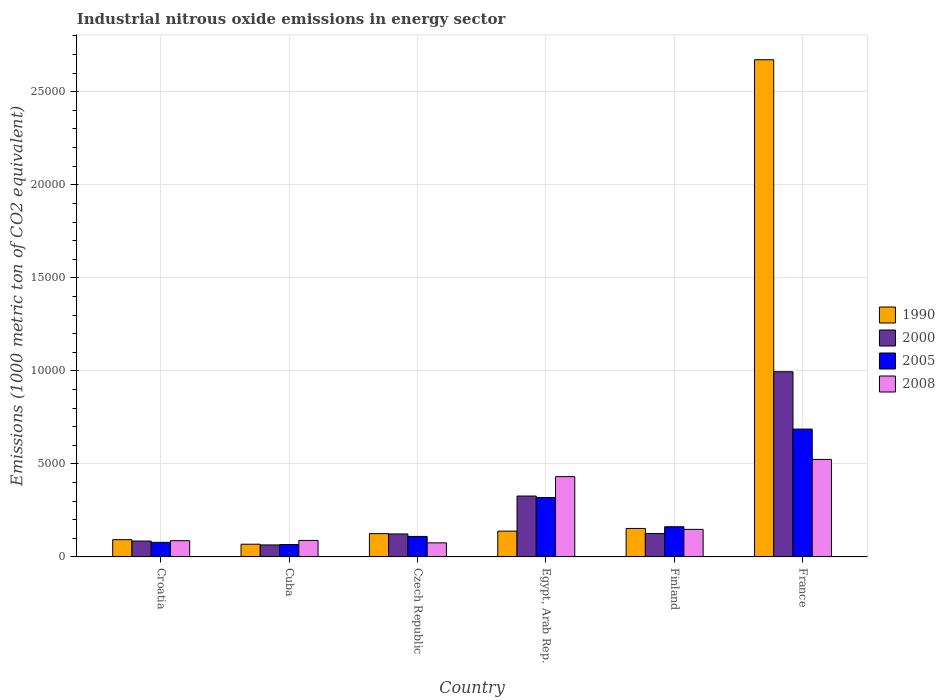How many groups of bars are there?
Give a very brief answer. 6. How many bars are there on the 3rd tick from the left?
Provide a succinct answer. 4. How many bars are there on the 3rd tick from the right?
Provide a short and direct response. 4. What is the label of the 5th group of bars from the left?
Ensure brevity in your answer.  Finland. What is the amount of industrial nitrous oxide emitted in 2000 in France?
Offer a terse response. 9953.8. Across all countries, what is the maximum amount of industrial nitrous oxide emitted in 2005?
Provide a succinct answer. 6871.6. Across all countries, what is the minimum amount of industrial nitrous oxide emitted in 2005?
Your answer should be very brief. 667.1. In which country was the amount of industrial nitrous oxide emitted in 1990 maximum?
Give a very brief answer. France. In which country was the amount of industrial nitrous oxide emitted in 2008 minimum?
Give a very brief answer. Czech Republic. What is the total amount of industrial nitrous oxide emitted in 2008 in the graph?
Keep it short and to the point. 1.36e+04. What is the difference between the amount of industrial nitrous oxide emitted in 2005 in Egypt, Arab Rep. and that in France?
Give a very brief answer. -3679. What is the difference between the amount of industrial nitrous oxide emitted in 2000 in Czech Republic and the amount of industrial nitrous oxide emitted in 2005 in Egypt, Arab Rep.?
Provide a short and direct response. -1957.2. What is the average amount of industrial nitrous oxide emitted in 1990 per country?
Offer a terse response. 5417.4. What is the difference between the amount of industrial nitrous oxide emitted of/in 2008 and amount of industrial nitrous oxide emitted of/in 1990 in France?
Your response must be concise. -2.15e+04. What is the ratio of the amount of industrial nitrous oxide emitted in 2000 in Croatia to that in Cuba?
Provide a succinct answer. 1.32. What is the difference between the highest and the second highest amount of industrial nitrous oxide emitted in 1990?
Provide a succinct answer. 2.52e+04. What is the difference between the highest and the lowest amount of industrial nitrous oxide emitted in 2000?
Make the answer very short. 9308.8. Is the sum of the amount of industrial nitrous oxide emitted in 2000 in Croatia and Finland greater than the maximum amount of industrial nitrous oxide emitted in 2005 across all countries?
Give a very brief answer. No. Is it the case that in every country, the sum of the amount of industrial nitrous oxide emitted in 1990 and amount of industrial nitrous oxide emitted in 2008 is greater than the sum of amount of industrial nitrous oxide emitted in 2005 and amount of industrial nitrous oxide emitted in 2000?
Give a very brief answer. No. What does the 4th bar from the left in Czech Republic represents?
Ensure brevity in your answer.  2008. What does the 4th bar from the right in Czech Republic represents?
Give a very brief answer. 1990. How many bars are there?
Offer a terse response. 24. Are all the bars in the graph horizontal?
Give a very brief answer. No. Does the graph contain grids?
Keep it short and to the point. Yes. Where does the legend appear in the graph?
Give a very brief answer. Center right. What is the title of the graph?
Your response must be concise. Industrial nitrous oxide emissions in energy sector. Does "1964" appear as one of the legend labels in the graph?
Give a very brief answer. No. What is the label or title of the Y-axis?
Ensure brevity in your answer.  Emissions (1000 metric ton of CO2 equivalent). What is the Emissions (1000 metric ton of CO2 equivalent) of 1990 in Croatia?
Your response must be concise. 927.7. What is the Emissions (1000 metric ton of CO2 equivalent) in 2000 in Croatia?
Offer a terse response. 854.3. What is the Emissions (1000 metric ton of CO2 equivalent) in 2005 in Croatia?
Ensure brevity in your answer.  783.2. What is the Emissions (1000 metric ton of CO2 equivalent) in 2008 in Croatia?
Give a very brief answer. 873. What is the Emissions (1000 metric ton of CO2 equivalent) in 1990 in Cuba?
Keep it short and to the point. 683.6. What is the Emissions (1000 metric ton of CO2 equivalent) of 2000 in Cuba?
Your answer should be very brief. 645. What is the Emissions (1000 metric ton of CO2 equivalent) of 2005 in Cuba?
Keep it short and to the point. 667.1. What is the Emissions (1000 metric ton of CO2 equivalent) in 2008 in Cuba?
Ensure brevity in your answer.  886.9. What is the Emissions (1000 metric ton of CO2 equivalent) of 1990 in Czech Republic?
Ensure brevity in your answer.  1253.3. What is the Emissions (1000 metric ton of CO2 equivalent) in 2000 in Czech Republic?
Make the answer very short. 1235.4. What is the Emissions (1000 metric ton of CO2 equivalent) of 2005 in Czech Republic?
Give a very brief answer. 1101.5. What is the Emissions (1000 metric ton of CO2 equivalent) of 2008 in Czech Republic?
Make the answer very short. 756. What is the Emissions (1000 metric ton of CO2 equivalent) of 1990 in Egypt, Arab Rep.?
Provide a succinct answer. 1386.6. What is the Emissions (1000 metric ton of CO2 equivalent) of 2000 in Egypt, Arab Rep.?
Offer a terse response. 3272.7. What is the Emissions (1000 metric ton of CO2 equivalent) of 2005 in Egypt, Arab Rep.?
Give a very brief answer. 3192.6. What is the Emissions (1000 metric ton of CO2 equivalent) of 2008 in Egypt, Arab Rep.?
Ensure brevity in your answer.  4315. What is the Emissions (1000 metric ton of CO2 equivalent) of 1990 in Finland?
Offer a very short reply. 1530.9. What is the Emissions (1000 metric ton of CO2 equivalent) in 2000 in Finland?
Your answer should be very brief. 1259.4. What is the Emissions (1000 metric ton of CO2 equivalent) in 2005 in Finland?
Your answer should be compact. 1622.4. What is the Emissions (1000 metric ton of CO2 equivalent) of 2008 in Finland?
Your answer should be very brief. 1481.5. What is the Emissions (1000 metric ton of CO2 equivalent) of 1990 in France?
Provide a short and direct response. 2.67e+04. What is the Emissions (1000 metric ton of CO2 equivalent) of 2000 in France?
Ensure brevity in your answer.  9953.8. What is the Emissions (1000 metric ton of CO2 equivalent) of 2005 in France?
Provide a succinct answer. 6871.6. What is the Emissions (1000 metric ton of CO2 equivalent) in 2008 in France?
Give a very brief answer. 5241.3. Across all countries, what is the maximum Emissions (1000 metric ton of CO2 equivalent) in 1990?
Offer a very short reply. 2.67e+04. Across all countries, what is the maximum Emissions (1000 metric ton of CO2 equivalent) of 2000?
Offer a terse response. 9953.8. Across all countries, what is the maximum Emissions (1000 metric ton of CO2 equivalent) of 2005?
Provide a short and direct response. 6871.6. Across all countries, what is the maximum Emissions (1000 metric ton of CO2 equivalent) in 2008?
Your answer should be compact. 5241.3. Across all countries, what is the minimum Emissions (1000 metric ton of CO2 equivalent) of 1990?
Give a very brief answer. 683.6. Across all countries, what is the minimum Emissions (1000 metric ton of CO2 equivalent) of 2000?
Give a very brief answer. 645. Across all countries, what is the minimum Emissions (1000 metric ton of CO2 equivalent) of 2005?
Your answer should be compact. 667.1. Across all countries, what is the minimum Emissions (1000 metric ton of CO2 equivalent) in 2008?
Make the answer very short. 756. What is the total Emissions (1000 metric ton of CO2 equivalent) in 1990 in the graph?
Make the answer very short. 3.25e+04. What is the total Emissions (1000 metric ton of CO2 equivalent) of 2000 in the graph?
Your response must be concise. 1.72e+04. What is the total Emissions (1000 metric ton of CO2 equivalent) in 2005 in the graph?
Your answer should be very brief. 1.42e+04. What is the total Emissions (1000 metric ton of CO2 equivalent) in 2008 in the graph?
Your answer should be very brief. 1.36e+04. What is the difference between the Emissions (1000 metric ton of CO2 equivalent) in 1990 in Croatia and that in Cuba?
Offer a terse response. 244.1. What is the difference between the Emissions (1000 metric ton of CO2 equivalent) of 2000 in Croatia and that in Cuba?
Your answer should be compact. 209.3. What is the difference between the Emissions (1000 metric ton of CO2 equivalent) in 2005 in Croatia and that in Cuba?
Provide a short and direct response. 116.1. What is the difference between the Emissions (1000 metric ton of CO2 equivalent) of 2008 in Croatia and that in Cuba?
Offer a terse response. -13.9. What is the difference between the Emissions (1000 metric ton of CO2 equivalent) in 1990 in Croatia and that in Czech Republic?
Offer a terse response. -325.6. What is the difference between the Emissions (1000 metric ton of CO2 equivalent) of 2000 in Croatia and that in Czech Republic?
Make the answer very short. -381.1. What is the difference between the Emissions (1000 metric ton of CO2 equivalent) of 2005 in Croatia and that in Czech Republic?
Your answer should be compact. -318.3. What is the difference between the Emissions (1000 metric ton of CO2 equivalent) of 2008 in Croatia and that in Czech Republic?
Your answer should be very brief. 117. What is the difference between the Emissions (1000 metric ton of CO2 equivalent) in 1990 in Croatia and that in Egypt, Arab Rep.?
Your answer should be compact. -458.9. What is the difference between the Emissions (1000 metric ton of CO2 equivalent) in 2000 in Croatia and that in Egypt, Arab Rep.?
Make the answer very short. -2418.4. What is the difference between the Emissions (1000 metric ton of CO2 equivalent) of 2005 in Croatia and that in Egypt, Arab Rep.?
Your answer should be compact. -2409.4. What is the difference between the Emissions (1000 metric ton of CO2 equivalent) in 2008 in Croatia and that in Egypt, Arab Rep.?
Keep it short and to the point. -3442. What is the difference between the Emissions (1000 metric ton of CO2 equivalent) in 1990 in Croatia and that in Finland?
Keep it short and to the point. -603.2. What is the difference between the Emissions (1000 metric ton of CO2 equivalent) in 2000 in Croatia and that in Finland?
Keep it short and to the point. -405.1. What is the difference between the Emissions (1000 metric ton of CO2 equivalent) of 2005 in Croatia and that in Finland?
Give a very brief answer. -839.2. What is the difference between the Emissions (1000 metric ton of CO2 equivalent) in 2008 in Croatia and that in Finland?
Ensure brevity in your answer.  -608.5. What is the difference between the Emissions (1000 metric ton of CO2 equivalent) in 1990 in Croatia and that in France?
Give a very brief answer. -2.58e+04. What is the difference between the Emissions (1000 metric ton of CO2 equivalent) in 2000 in Croatia and that in France?
Offer a terse response. -9099.5. What is the difference between the Emissions (1000 metric ton of CO2 equivalent) of 2005 in Croatia and that in France?
Your response must be concise. -6088.4. What is the difference between the Emissions (1000 metric ton of CO2 equivalent) in 2008 in Croatia and that in France?
Offer a terse response. -4368.3. What is the difference between the Emissions (1000 metric ton of CO2 equivalent) in 1990 in Cuba and that in Czech Republic?
Ensure brevity in your answer.  -569.7. What is the difference between the Emissions (1000 metric ton of CO2 equivalent) of 2000 in Cuba and that in Czech Republic?
Offer a very short reply. -590.4. What is the difference between the Emissions (1000 metric ton of CO2 equivalent) in 2005 in Cuba and that in Czech Republic?
Make the answer very short. -434.4. What is the difference between the Emissions (1000 metric ton of CO2 equivalent) of 2008 in Cuba and that in Czech Republic?
Keep it short and to the point. 130.9. What is the difference between the Emissions (1000 metric ton of CO2 equivalent) in 1990 in Cuba and that in Egypt, Arab Rep.?
Provide a short and direct response. -703. What is the difference between the Emissions (1000 metric ton of CO2 equivalent) in 2000 in Cuba and that in Egypt, Arab Rep.?
Offer a very short reply. -2627.7. What is the difference between the Emissions (1000 metric ton of CO2 equivalent) in 2005 in Cuba and that in Egypt, Arab Rep.?
Make the answer very short. -2525.5. What is the difference between the Emissions (1000 metric ton of CO2 equivalent) in 2008 in Cuba and that in Egypt, Arab Rep.?
Give a very brief answer. -3428.1. What is the difference between the Emissions (1000 metric ton of CO2 equivalent) in 1990 in Cuba and that in Finland?
Provide a short and direct response. -847.3. What is the difference between the Emissions (1000 metric ton of CO2 equivalent) of 2000 in Cuba and that in Finland?
Your response must be concise. -614.4. What is the difference between the Emissions (1000 metric ton of CO2 equivalent) in 2005 in Cuba and that in Finland?
Offer a very short reply. -955.3. What is the difference between the Emissions (1000 metric ton of CO2 equivalent) of 2008 in Cuba and that in Finland?
Provide a succinct answer. -594.6. What is the difference between the Emissions (1000 metric ton of CO2 equivalent) in 1990 in Cuba and that in France?
Provide a succinct answer. -2.60e+04. What is the difference between the Emissions (1000 metric ton of CO2 equivalent) of 2000 in Cuba and that in France?
Make the answer very short. -9308.8. What is the difference between the Emissions (1000 metric ton of CO2 equivalent) of 2005 in Cuba and that in France?
Provide a short and direct response. -6204.5. What is the difference between the Emissions (1000 metric ton of CO2 equivalent) of 2008 in Cuba and that in France?
Provide a succinct answer. -4354.4. What is the difference between the Emissions (1000 metric ton of CO2 equivalent) in 1990 in Czech Republic and that in Egypt, Arab Rep.?
Your answer should be very brief. -133.3. What is the difference between the Emissions (1000 metric ton of CO2 equivalent) of 2000 in Czech Republic and that in Egypt, Arab Rep.?
Offer a terse response. -2037.3. What is the difference between the Emissions (1000 metric ton of CO2 equivalent) of 2005 in Czech Republic and that in Egypt, Arab Rep.?
Provide a succinct answer. -2091.1. What is the difference between the Emissions (1000 metric ton of CO2 equivalent) in 2008 in Czech Republic and that in Egypt, Arab Rep.?
Make the answer very short. -3559. What is the difference between the Emissions (1000 metric ton of CO2 equivalent) of 1990 in Czech Republic and that in Finland?
Provide a short and direct response. -277.6. What is the difference between the Emissions (1000 metric ton of CO2 equivalent) in 2000 in Czech Republic and that in Finland?
Offer a very short reply. -24. What is the difference between the Emissions (1000 metric ton of CO2 equivalent) of 2005 in Czech Republic and that in Finland?
Offer a terse response. -520.9. What is the difference between the Emissions (1000 metric ton of CO2 equivalent) in 2008 in Czech Republic and that in Finland?
Offer a terse response. -725.5. What is the difference between the Emissions (1000 metric ton of CO2 equivalent) in 1990 in Czech Republic and that in France?
Your response must be concise. -2.55e+04. What is the difference between the Emissions (1000 metric ton of CO2 equivalent) of 2000 in Czech Republic and that in France?
Provide a succinct answer. -8718.4. What is the difference between the Emissions (1000 metric ton of CO2 equivalent) in 2005 in Czech Republic and that in France?
Your response must be concise. -5770.1. What is the difference between the Emissions (1000 metric ton of CO2 equivalent) in 2008 in Czech Republic and that in France?
Offer a very short reply. -4485.3. What is the difference between the Emissions (1000 metric ton of CO2 equivalent) in 1990 in Egypt, Arab Rep. and that in Finland?
Offer a terse response. -144.3. What is the difference between the Emissions (1000 metric ton of CO2 equivalent) of 2000 in Egypt, Arab Rep. and that in Finland?
Ensure brevity in your answer.  2013.3. What is the difference between the Emissions (1000 metric ton of CO2 equivalent) in 2005 in Egypt, Arab Rep. and that in Finland?
Offer a terse response. 1570.2. What is the difference between the Emissions (1000 metric ton of CO2 equivalent) in 2008 in Egypt, Arab Rep. and that in Finland?
Offer a very short reply. 2833.5. What is the difference between the Emissions (1000 metric ton of CO2 equivalent) in 1990 in Egypt, Arab Rep. and that in France?
Provide a succinct answer. -2.53e+04. What is the difference between the Emissions (1000 metric ton of CO2 equivalent) in 2000 in Egypt, Arab Rep. and that in France?
Your response must be concise. -6681.1. What is the difference between the Emissions (1000 metric ton of CO2 equivalent) in 2005 in Egypt, Arab Rep. and that in France?
Your answer should be very brief. -3679. What is the difference between the Emissions (1000 metric ton of CO2 equivalent) of 2008 in Egypt, Arab Rep. and that in France?
Your response must be concise. -926.3. What is the difference between the Emissions (1000 metric ton of CO2 equivalent) of 1990 in Finland and that in France?
Offer a very short reply. -2.52e+04. What is the difference between the Emissions (1000 metric ton of CO2 equivalent) of 2000 in Finland and that in France?
Your response must be concise. -8694.4. What is the difference between the Emissions (1000 metric ton of CO2 equivalent) in 2005 in Finland and that in France?
Offer a very short reply. -5249.2. What is the difference between the Emissions (1000 metric ton of CO2 equivalent) in 2008 in Finland and that in France?
Make the answer very short. -3759.8. What is the difference between the Emissions (1000 metric ton of CO2 equivalent) of 1990 in Croatia and the Emissions (1000 metric ton of CO2 equivalent) of 2000 in Cuba?
Give a very brief answer. 282.7. What is the difference between the Emissions (1000 metric ton of CO2 equivalent) in 1990 in Croatia and the Emissions (1000 metric ton of CO2 equivalent) in 2005 in Cuba?
Provide a succinct answer. 260.6. What is the difference between the Emissions (1000 metric ton of CO2 equivalent) of 1990 in Croatia and the Emissions (1000 metric ton of CO2 equivalent) of 2008 in Cuba?
Offer a very short reply. 40.8. What is the difference between the Emissions (1000 metric ton of CO2 equivalent) of 2000 in Croatia and the Emissions (1000 metric ton of CO2 equivalent) of 2005 in Cuba?
Offer a terse response. 187.2. What is the difference between the Emissions (1000 metric ton of CO2 equivalent) in 2000 in Croatia and the Emissions (1000 metric ton of CO2 equivalent) in 2008 in Cuba?
Make the answer very short. -32.6. What is the difference between the Emissions (1000 metric ton of CO2 equivalent) in 2005 in Croatia and the Emissions (1000 metric ton of CO2 equivalent) in 2008 in Cuba?
Offer a very short reply. -103.7. What is the difference between the Emissions (1000 metric ton of CO2 equivalent) of 1990 in Croatia and the Emissions (1000 metric ton of CO2 equivalent) of 2000 in Czech Republic?
Provide a short and direct response. -307.7. What is the difference between the Emissions (1000 metric ton of CO2 equivalent) in 1990 in Croatia and the Emissions (1000 metric ton of CO2 equivalent) in 2005 in Czech Republic?
Provide a short and direct response. -173.8. What is the difference between the Emissions (1000 metric ton of CO2 equivalent) in 1990 in Croatia and the Emissions (1000 metric ton of CO2 equivalent) in 2008 in Czech Republic?
Your answer should be very brief. 171.7. What is the difference between the Emissions (1000 metric ton of CO2 equivalent) of 2000 in Croatia and the Emissions (1000 metric ton of CO2 equivalent) of 2005 in Czech Republic?
Your response must be concise. -247.2. What is the difference between the Emissions (1000 metric ton of CO2 equivalent) in 2000 in Croatia and the Emissions (1000 metric ton of CO2 equivalent) in 2008 in Czech Republic?
Make the answer very short. 98.3. What is the difference between the Emissions (1000 metric ton of CO2 equivalent) in 2005 in Croatia and the Emissions (1000 metric ton of CO2 equivalent) in 2008 in Czech Republic?
Provide a succinct answer. 27.2. What is the difference between the Emissions (1000 metric ton of CO2 equivalent) in 1990 in Croatia and the Emissions (1000 metric ton of CO2 equivalent) in 2000 in Egypt, Arab Rep.?
Ensure brevity in your answer.  -2345. What is the difference between the Emissions (1000 metric ton of CO2 equivalent) in 1990 in Croatia and the Emissions (1000 metric ton of CO2 equivalent) in 2005 in Egypt, Arab Rep.?
Ensure brevity in your answer.  -2264.9. What is the difference between the Emissions (1000 metric ton of CO2 equivalent) in 1990 in Croatia and the Emissions (1000 metric ton of CO2 equivalent) in 2008 in Egypt, Arab Rep.?
Keep it short and to the point. -3387.3. What is the difference between the Emissions (1000 metric ton of CO2 equivalent) in 2000 in Croatia and the Emissions (1000 metric ton of CO2 equivalent) in 2005 in Egypt, Arab Rep.?
Give a very brief answer. -2338.3. What is the difference between the Emissions (1000 metric ton of CO2 equivalent) of 2000 in Croatia and the Emissions (1000 metric ton of CO2 equivalent) of 2008 in Egypt, Arab Rep.?
Give a very brief answer. -3460.7. What is the difference between the Emissions (1000 metric ton of CO2 equivalent) of 2005 in Croatia and the Emissions (1000 metric ton of CO2 equivalent) of 2008 in Egypt, Arab Rep.?
Your answer should be very brief. -3531.8. What is the difference between the Emissions (1000 metric ton of CO2 equivalent) in 1990 in Croatia and the Emissions (1000 metric ton of CO2 equivalent) in 2000 in Finland?
Provide a short and direct response. -331.7. What is the difference between the Emissions (1000 metric ton of CO2 equivalent) of 1990 in Croatia and the Emissions (1000 metric ton of CO2 equivalent) of 2005 in Finland?
Make the answer very short. -694.7. What is the difference between the Emissions (1000 metric ton of CO2 equivalent) in 1990 in Croatia and the Emissions (1000 metric ton of CO2 equivalent) in 2008 in Finland?
Make the answer very short. -553.8. What is the difference between the Emissions (1000 metric ton of CO2 equivalent) of 2000 in Croatia and the Emissions (1000 metric ton of CO2 equivalent) of 2005 in Finland?
Keep it short and to the point. -768.1. What is the difference between the Emissions (1000 metric ton of CO2 equivalent) of 2000 in Croatia and the Emissions (1000 metric ton of CO2 equivalent) of 2008 in Finland?
Give a very brief answer. -627.2. What is the difference between the Emissions (1000 metric ton of CO2 equivalent) of 2005 in Croatia and the Emissions (1000 metric ton of CO2 equivalent) of 2008 in Finland?
Offer a very short reply. -698.3. What is the difference between the Emissions (1000 metric ton of CO2 equivalent) in 1990 in Croatia and the Emissions (1000 metric ton of CO2 equivalent) in 2000 in France?
Your response must be concise. -9026.1. What is the difference between the Emissions (1000 metric ton of CO2 equivalent) in 1990 in Croatia and the Emissions (1000 metric ton of CO2 equivalent) in 2005 in France?
Your answer should be compact. -5943.9. What is the difference between the Emissions (1000 metric ton of CO2 equivalent) in 1990 in Croatia and the Emissions (1000 metric ton of CO2 equivalent) in 2008 in France?
Give a very brief answer. -4313.6. What is the difference between the Emissions (1000 metric ton of CO2 equivalent) in 2000 in Croatia and the Emissions (1000 metric ton of CO2 equivalent) in 2005 in France?
Ensure brevity in your answer.  -6017.3. What is the difference between the Emissions (1000 metric ton of CO2 equivalent) of 2000 in Croatia and the Emissions (1000 metric ton of CO2 equivalent) of 2008 in France?
Your answer should be compact. -4387. What is the difference between the Emissions (1000 metric ton of CO2 equivalent) in 2005 in Croatia and the Emissions (1000 metric ton of CO2 equivalent) in 2008 in France?
Offer a very short reply. -4458.1. What is the difference between the Emissions (1000 metric ton of CO2 equivalent) in 1990 in Cuba and the Emissions (1000 metric ton of CO2 equivalent) in 2000 in Czech Republic?
Make the answer very short. -551.8. What is the difference between the Emissions (1000 metric ton of CO2 equivalent) of 1990 in Cuba and the Emissions (1000 metric ton of CO2 equivalent) of 2005 in Czech Republic?
Ensure brevity in your answer.  -417.9. What is the difference between the Emissions (1000 metric ton of CO2 equivalent) in 1990 in Cuba and the Emissions (1000 metric ton of CO2 equivalent) in 2008 in Czech Republic?
Offer a very short reply. -72.4. What is the difference between the Emissions (1000 metric ton of CO2 equivalent) of 2000 in Cuba and the Emissions (1000 metric ton of CO2 equivalent) of 2005 in Czech Republic?
Your answer should be very brief. -456.5. What is the difference between the Emissions (1000 metric ton of CO2 equivalent) in 2000 in Cuba and the Emissions (1000 metric ton of CO2 equivalent) in 2008 in Czech Republic?
Keep it short and to the point. -111. What is the difference between the Emissions (1000 metric ton of CO2 equivalent) of 2005 in Cuba and the Emissions (1000 metric ton of CO2 equivalent) of 2008 in Czech Republic?
Keep it short and to the point. -88.9. What is the difference between the Emissions (1000 metric ton of CO2 equivalent) of 1990 in Cuba and the Emissions (1000 metric ton of CO2 equivalent) of 2000 in Egypt, Arab Rep.?
Provide a succinct answer. -2589.1. What is the difference between the Emissions (1000 metric ton of CO2 equivalent) in 1990 in Cuba and the Emissions (1000 metric ton of CO2 equivalent) in 2005 in Egypt, Arab Rep.?
Give a very brief answer. -2509. What is the difference between the Emissions (1000 metric ton of CO2 equivalent) in 1990 in Cuba and the Emissions (1000 metric ton of CO2 equivalent) in 2008 in Egypt, Arab Rep.?
Your response must be concise. -3631.4. What is the difference between the Emissions (1000 metric ton of CO2 equivalent) of 2000 in Cuba and the Emissions (1000 metric ton of CO2 equivalent) of 2005 in Egypt, Arab Rep.?
Your response must be concise. -2547.6. What is the difference between the Emissions (1000 metric ton of CO2 equivalent) of 2000 in Cuba and the Emissions (1000 metric ton of CO2 equivalent) of 2008 in Egypt, Arab Rep.?
Offer a very short reply. -3670. What is the difference between the Emissions (1000 metric ton of CO2 equivalent) in 2005 in Cuba and the Emissions (1000 metric ton of CO2 equivalent) in 2008 in Egypt, Arab Rep.?
Provide a succinct answer. -3647.9. What is the difference between the Emissions (1000 metric ton of CO2 equivalent) in 1990 in Cuba and the Emissions (1000 metric ton of CO2 equivalent) in 2000 in Finland?
Ensure brevity in your answer.  -575.8. What is the difference between the Emissions (1000 metric ton of CO2 equivalent) of 1990 in Cuba and the Emissions (1000 metric ton of CO2 equivalent) of 2005 in Finland?
Your answer should be very brief. -938.8. What is the difference between the Emissions (1000 metric ton of CO2 equivalent) in 1990 in Cuba and the Emissions (1000 metric ton of CO2 equivalent) in 2008 in Finland?
Keep it short and to the point. -797.9. What is the difference between the Emissions (1000 metric ton of CO2 equivalent) of 2000 in Cuba and the Emissions (1000 metric ton of CO2 equivalent) of 2005 in Finland?
Ensure brevity in your answer.  -977.4. What is the difference between the Emissions (1000 metric ton of CO2 equivalent) of 2000 in Cuba and the Emissions (1000 metric ton of CO2 equivalent) of 2008 in Finland?
Offer a very short reply. -836.5. What is the difference between the Emissions (1000 metric ton of CO2 equivalent) of 2005 in Cuba and the Emissions (1000 metric ton of CO2 equivalent) of 2008 in Finland?
Ensure brevity in your answer.  -814.4. What is the difference between the Emissions (1000 metric ton of CO2 equivalent) of 1990 in Cuba and the Emissions (1000 metric ton of CO2 equivalent) of 2000 in France?
Provide a succinct answer. -9270.2. What is the difference between the Emissions (1000 metric ton of CO2 equivalent) of 1990 in Cuba and the Emissions (1000 metric ton of CO2 equivalent) of 2005 in France?
Provide a short and direct response. -6188. What is the difference between the Emissions (1000 metric ton of CO2 equivalent) of 1990 in Cuba and the Emissions (1000 metric ton of CO2 equivalent) of 2008 in France?
Offer a terse response. -4557.7. What is the difference between the Emissions (1000 metric ton of CO2 equivalent) in 2000 in Cuba and the Emissions (1000 metric ton of CO2 equivalent) in 2005 in France?
Provide a short and direct response. -6226.6. What is the difference between the Emissions (1000 metric ton of CO2 equivalent) in 2000 in Cuba and the Emissions (1000 metric ton of CO2 equivalent) in 2008 in France?
Ensure brevity in your answer.  -4596.3. What is the difference between the Emissions (1000 metric ton of CO2 equivalent) in 2005 in Cuba and the Emissions (1000 metric ton of CO2 equivalent) in 2008 in France?
Keep it short and to the point. -4574.2. What is the difference between the Emissions (1000 metric ton of CO2 equivalent) of 1990 in Czech Republic and the Emissions (1000 metric ton of CO2 equivalent) of 2000 in Egypt, Arab Rep.?
Offer a very short reply. -2019.4. What is the difference between the Emissions (1000 metric ton of CO2 equivalent) of 1990 in Czech Republic and the Emissions (1000 metric ton of CO2 equivalent) of 2005 in Egypt, Arab Rep.?
Offer a very short reply. -1939.3. What is the difference between the Emissions (1000 metric ton of CO2 equivalent) of 1990 in Czech Republic and the Emissions (1000 metric ton of CO2 equivalent) of 2008 in Egypt, Arab Rep.?
Your answer should be very brief. -3061.7. What is the difference between the Emissions (1000 metric ton of CO2 equivalent) in 2000 in Czech Republic and the Emissions (1000 metric ton of CO2 equivalent) in 2005 in Egypt, Arab Rep.?
Give a very brief answer. -1957.2. What is the difference between the Emissions (1000 metric ton of CO2 equivalent) in 2000 in Czech Republic and the Emissions (1000 metric ton of CO2 equivalent) in 2008 in Egypt, Arab Rep.?
Offer a very short reply. -3079.6. What is the difference between the Emissions (1000 metric ton of CO2 equivalent) in 2005 in Czech Republic and the Emissions (1000 metric ton of CO2 equivalent) in 2008 in Egypt, Arab Rep.?
Offer a very short reply. -3213.5. What is the difference between the Emissions (1000 metric ton of CO2 equivalent) of 1990 in Czech Republic and the Emissions (1000 metric ton of CO2 equivalent) of 2000 in Finland?
Keep it short and to the point. -6.1. What is the difference between the Emissions (1000 metric ton of CO2 equivalent) of 1990 in Czech Republic and the Emissions (1000 metric ton of CO2 equivalent) of 2005 in Finland?
Offer a terse response. -369.1. What is the difference between the Emissions (1000 metric ton of CO2 equivalent) in 1990 in Czech Republic and the Emissions (1000 metric ton of CO2 equivalent) in 2008 in Finland?
Your answer should be very brief. -228.2. What is the difference between the Emissions (1000 metric ton of CO2 equivalent) in 2000 in Czech Republic and the Emissions (1000 metric ton of CO2 equivalent) in 2005 in Finland?
Your answer should be very brief. -387. What is the difference between the Emissions (1000 metric ton of CO2 equivalent) of 2000 in Czech Republic and the Emissions (1000 metric ton of CO2 equivalent) of 2008 in Finland?
Offer a very short reply. -246.1. What is the difference between the Emissions (1000 metric ton of CO2 equivalent) of 2005 in Czech Republic and the Emissions (1000 metric ton of CO2 equivalent) of 2008 in Finland?
Your response must be concise. -380. What is the difference between the Emissions (1000 metric ton of CO2 equivalent) of 1990 in Czech Republic and the Emissions (1000 metric ton of CO2 equivalent) of 2000 in France?
Ensure brevity in your answer.  -8700.5. What is the difference between the Emissions (1000 metric ton of CO2 equivalent) in 1990 in Czech Republic and the Emissions (1000 metric ton of CO2 equivalent) in 2005 in France?
Offer a terse response. -5618.3. What is the difference between the Emissions (1000 metric ton of CO2 equivalent) in 1990 in Czech Republic and the Emissions (1000 metric ton of CO2 equivalent) in 2008 in France?
Keep it short and to the point. -3988. What is the difference between the Emissions (1000 metric ton of CO2 equivalent) in 2000 in Czech Republic and the Emissions (1000 metric ton of CO2 equivalent) in 2005 in France?
Your answer should be very brief. -5636.2. What is the difference between the Emissions (1000 metric ton of CO2 equivalent) of 2000 in Czech Republic and the Emissions (1000 metric ton of CO2 equivalent) of 2008 in France?
Your answer should be compact. -4005.9. What is the difference between the Emissions (1000 metric ton of CO2 equivalent) in 2005 in Czech Republic and the Emissions (1000 metric ton of CO2 equivalent) in 2008 in France?
Provide a succinct answer. -4139.8. What is the difference between the Emissions (1000 metric ton of CO2 equivalent) in 1990 in Egypt, Arab Rep. and the Emissions (1000 metric ton of CO2 equivalent) in 2000 in Finland?
Provide a succinct answer. 127.2. What is the difference between the Emissions (1000 metric ton of CO2 equivalent) in 1990 in Egypt, Arab Rep. and the Emissions (1000 metric ton of CO2 equivalent) in 2005 in Finland?
Your response must be concise. -235.8. What is the difference between the Emissions (1000 metric ton of CO2 equivalent) of 1990 in Egypt, Arab Rep. and the Emissions (1000 metric ton of CO2 equivalent) of 2008 in Finland?
Provide a succinct answer. -94.9. What is the difference between the Emissions (1000 metric ton of CO2 equivalent) in 2000 in Egypt, Arab Rep. and the Emissions (1000 metric ton of CO2 equivalent) in 2005 in Finland?
Give a very brief answer. 1650.3. What is the difference between the Emissions (1000 metric ton of CO2 equivalent) of 2000 in Egypt, Arab Rep. and the Emissions (1000 metric ton of CO2 equivalent) of 2008 in Finland?
Ensure brevity in your answer.  1791.2. What is the difference between the Emissions (1000 metric ton of CO2 equivalent) of 2005 in Egypt, Arab Rep. and the Emissions (1000 metric ton of CO2 equivalent) of 2008 in Finland?
Make the answer very short. 1711.1. What is the difference between the Emissions (1000 metric ton of CO2 equivalent) in 1990 in Egypt, Arab Rep. and the Emissions (1000 metric ton of CO2 equivalent) in 2000 in France?
Ensure brevity in your answer.  -8567.2. What is the difference between the Emissions (1000 metric ton of CO2 equivalent) in 1990 in Egypt, Arab Rep. and the Emissions (1000 metric ton of CO2 equivalent) in 2005 in France?
Your answer should be very brief. -5485. What is the difference between the Emissions (1000 metric ton of CO2 equivalent) of 1990 in Egypt, Arab Rep. and the Emissions (1000 metric ton of CO2 equivalent) of 2008 in France?
Keep it short and to the point. -3854.7. What is the difference between the Emissions (1000 metric ton of CO2 equivalent) of 2000 in Egypt, Arab Rep. and the Emissions (1000 metric ton of CO2 equivalent) of 2005 in France?
Your answer should be compact. -3598.9. What is the difference between the Emissions (1000 metric ton of CO2 equivalent) of 2000 in Egypt, Arab Rep. and the Emissions (1000 metric ton of CO2 equivalent) of 2008 in France?
Keep it short and to the point. -1968.6. What is the difference between the Emissions (1000 metric ton of CO2 equivalent) of 2005 in Egypt, Arab Rep. and the Emissions (1000 metric ton of CO2 equivalent) of 2008 in France?
Give a very brief answer. -2048.7. What is the difference between the Emissions (1000 metric ton of CO2 equivalent) in 1990 in Finland and the Emissions (1000 metric ton of CO2 equivalent) in 2000 in France?
Your answer should be very brief. -8422.9. What is the difference between the Emissions (1000 metric ton of CO2 equivalent) in 1990 in Finland and the Emissions (1000 metric ton of CO2 equivalent) in 2005 in France?
Ensure brevity in your answer.  -5340.7. What is the difference between the Emissions (1000 metric ton of CO2 equivalent) of 1990 in Finland and the Emissions (1000 metric ton of CO2 equivalent) of 2008 in France?
Ensure brevity in your answer.  -3710.4. What is the difference between the Emissions (1000 metric ton of CO2 equivalent) in 2000 in Finland and the Emissions (1000 metric ton of CO2 equivalent) in 2005 in France?
Provide a succinct answer. -5612.2. What is the difference between the Emissions (1000 metric ton of CO2 equivalent) in 2000 in Finland and the Emissions (1000 metric ton of CO2 equivalent) in 2008 in France?
Provide a succinct answer. -3981.9. What is the difference between the Emissions (1000 metric ton of CO2 equivalent) of 2005 in Finland and the Emissions (1000 metric ton of CO2 equivalent) of 2008 in France?
Provide a succinct answer. -3618.9. What is the average Emissions (1000 metric ton of CO2 equivalent) of 1990 per country?
Give a very brief answer. 5417.4. What is the average Emissions (1000 metric ton of CO2 equivalent) in 2000 per country?
Make the answer very short. 2870.1. What is the average Emissions (1000 metric ton of CO2 equivalent) in 2005 per country?
Provide a succinct answer. 2373.07. What is the average Emissions (1000 metric ton of CO2 equivalent) in 2008 per country?
Ensure brevity in your answer.  2258.95. What is the difference between the Emissions (1000 metric ton of CO2 equivalent) of 1990 and Emissions (1000 metric ton of CO2 equivalent) of 2000 in Croatia?
Provide a succinct answer. 73.4. What is the difference between the Emissions (1000 metric ton of CO2 equivalent) of 1990 and Emissions (1000 metric ton of CO2 equivalent) of 2005 in Croatia?
Keep it short and to the point. 144.5. What is the difference between the Emissions (1000 metric ton of CO2 equivalent) in 1990 and Emissions (1000 metric ton of CO2 equivalent) in 2008 in Croatia?
Keep it short and to the point. 54.7. What is the difference between the Emissions (1000 metric ton of CO2 equivalent) of 2000 and Emissions (1000 metric ton of CO2 equivalent) of 2005 in Croatia?
Give a very brief answer. 71.1. What is the difference between the Emissions (1000 metric ton of CO2 equivalent) of 2000 and Emissions (1000 metric ton of CO2 equivalent) of 2008 in Croatia?
Offer a very short reply. -18.7. What is the difference between the Emissions (1000 metric ton of CO2 equivalent) of 2005 and Emissions (1000 metric ton of CO2 equivalent) of 2008 in Croatia?
Your response must be concise. -89.8. What is the difference between the Emissions (1000 metric ton of CO2 equivalent) of 1990 and Emissions (1000 metric ton of CO2 equivalent) of 2000 in Cuba?
Your answer should be compact. 38.6. What is the difference between the Emissions (1000 metric ton of CO2 equivalent) of 1990 and Emissions (1000 metric ton of CO2 equivalent) of 2005 in Cuba?
Your response must be concise. 16.5. What is the difference between the Emissions (1000 metric ton of CO2 equivalent) of 1990 and Emissions (1000 metric ton of CO2 equivalent) of 2008 in Cuba?
Provide a short and direct response. -203.3. What is the difference between the Emissions (1000 metric ton of CO2 equivalent) of 2000 and Emissions (1000 metric ton of CO2 equivalent) of 2005 in Cuba?
Your answer should be compact. -22.1. What is the difference between the Emissions (1000 metric ton of CO2 equivalent) of 2000 and Emissions (1000 metric ton of CO2 equivalent) of 2008 in Cuba?
Give a very brief answer. -241.9. What is the difference between the Emissions (1000 metric ton of CO2 equivalent) in 2005 and Emissions (1000 metric ton of CO2 equivalent) in 2008 in Cuba?
Make the answer very short. -219.8. What is the difference between the Emissions (1000 metric ton of CO2 equivalent) of 1990 and Emissions (1000 metric ton of CO2 equivalent) of 2005 in Czech Republic?
Give a very brief answer. 151.8. What is the difference between the Emissions (1000 metric ton of CO2 equivalent) of 1990 and Emissions (1000 metric ton of CO2 equivalent) of 2008 in Czech Republic?
Keep it short and to the point. 497.3. What is the difference between the Emissions (1000 metric ton of CO2 equivalent) of 2000 and Emissions (1000 metric ton of CO2 equivalent) of 2005 in Czech Republic?
Your answer should be compact. 133.9. What is the difference between the Emissions (1000 metric ton of CO2 equivalent) in 2000 and Emissions (1000 metric ton of CO2 equivalent) in 2008 in Czech Republic?
Provide a short and direct response. 479.4. What is the difference between the Emissions (1000 metric ton of CO2 equivalent) of 2005 and Emissions (1000 metric ton of CO2 equivalent) of 2008 in Czech Republic?
Offer a very short reply. 345.5. What is the difference between the Emissions (1000 metric ton of CO2 equivalent) of 1990 and Emissions (1000 metric ton of CO2 equivalent) of 2000 in Egypt, Arab Rep.?
Give a very brief answer. -1886.1. What is the difference between the Emissions (1000 metric ton of CO2 equivalent) of 1990 and Emissions (1000 metric ton of CO2 equivalent) of 2005 in Egypt, Arab Rep.?
Your answer should be very brief. -1806. What is the difference between the Emissions (1000 metric ton of CO2 equivalent) of 1990 and Emissions (1000 metric ton of CO2 equivalent) of 2008 in Egypt, Arab Rep.?
Your response must be concise. -2928.4. What is the difference between the Emissions (1000 metric ton of CO2 equivalent) of 2000 and Emissions (1000 metric ton of CO2 equivalent) of 2005 in Egypt, Arab Rep.?
Provide a succinct answer. 80.1. What is the difference between the Emissions (1000 metric ton of CO2 equivalent) of 2000 and Emissions (1000 metric ton of CO2 equivalent) of 2008 in Egypt, Arab Rep.?
Provide a succinct answer. -1042.3. What is the difference between the Emissions (1000 metric ton of CO2 equivalent) in 2005 and Emissions (1000 metric ton of CO2 equivalent) in 2008 in Egypt, Arab Rep.?
Provide a succinct answer. -1122.4. What is the difference between the Emissions (1000 metric ton of CO2 equivalent) in 1990 and Emissions (1000 metric ton of CO2 equivalent) in 2000 in Finland?
Give a very brief answer. 271.5. What is the difference between the Emissions (1000 metric ton of CO2 equivalent) in 1990 and Emissions (1000 metric ton of CO2 equivalent) in 2005 in Finland?
Keep it short and to the point. -91.5. What is the difference between the Emissions (1000 metric ton of CO2 equivalent) of 1990 and Emissions (1000 metric ton of CO2 equivalent) of 2008 in Finland?
Keep it short and to the point. 49.4. What is the difference between the Emissions (1000 metric ton of CO2 equivalent) in 2000 and Emissions (1000 metric ton of CO2 equivalent) in 2005 in Finland?
Provide a succinct answer. -363. What is the difference between the Emissions (1000 metric ton of CO2 equivalent) of 2000 and Emissions (1000 metric ton of CO2 equivalent) of 2008 in Finland?
Ensure brevity in your answer.  -222.1. What is the difference between the Emissions (1000 metric ton of CO2 equivalent) in 2005 and Emissions (1000 metric ton of CO2 equivalent) in 2008 in Finland?
Offer a terse response. 140.9. What is the difference between the Emissions (1000 metric ton of CO2 equivalent) in 1990 and Emissions (1000 metric ton of CO2 equivalent) in 2000 in France?
Keep it short and to the point. 1.68e+04. What is the difference between the Emissions (1000 metric ton of CO2 equivalent) of 1990 and Emissions (1000 metric ton of CO2 equivalent) of 2005 in France?
Provide a succinct answer. 1.99e+04. What is the difference between the Emissions (1000 metric ton of CO2 equivalent) in 1990 and Emissions (1000 metric ton of CO2 equivalent) in 2008 in France?
Offer a very short reply. 2.15e+04. What is the difference between the Emissions (1000 metric ton of CO2 equivalent) in 2000 and Emissions (1000 metric ton of CO2 equivalent) in 2005 in France?
Make the answer very short. 3082.2. What is the difference between the Emissions (1000 metric ton of CO2 equivalent) of 2000 and Emissions (1000 metric ton of CO2 equivalent) of 2008 in France?
Make the answer very short. 4712.5. What is the difference between the Emissions (1000 metric ton of CO2 equivalent) of 2005 and Emissions (1000 metric ton of CO2 equivalent) of 2008 in France?
Your answer should be very brief. 1630.3. What is the ratio of the Emissions (1000 metric ton of CO2 equivalent) in 1990 in Croatia to that in Cuba?
Your response must be concise. 1.36. What is the ratio of the Emissions (1000 metric ton of CO2 equivalent) in 2000 in Croatia to that in Cuba?
Offer a terse response. 1.32. What is the ratio of the Emissions (1000 metric ton of CO2 equivalent) in 2005 in Croatia to that in Cuba?
Your answer should be compact. 1.17. What is the ratio of the Emissions (1000 metric ton of CO2 equivalent) in 2008 in Croatia to that in Cuba?
Ensure brevity in your answer.  0.98. What is the ratio of the Emissions (1000 metric ton of CO2 equivalent) in 1990 in Croatia to that in Czech Republic?
Keep it short and to the point. 0.74. What is the ratio of the Emissions (1000 metric ton of CO2 equivalent) of 2000 in Croatia to that in Czech Republic?
Keep it short and to the point. 0.69. What is the ratio of the Emissions (1000 metric ton of CO2 equivalent) in 2005 in Croatia to that in Czech Republic?
Give a very brief answer. 0.71. What is the ratio of the Emissions (1000 metric ton of CO2 equivalent) of 2008 in Croatia to that in Czech Republic?
Keep it short and to the point. 1.15. What is the ratio of the Emissions (1000 metric ton of CO2 equivalent) in 1990 in Croatia to that in Egypt, Arab Rep.?
Your answer should be compact. 0.67. What is the ratio of the Emissions (1000 metric ton of CO2 equivalent) of 2000 in Croatia to that in Egypt, Arab Rep.?
Keep it short and to the point. 0.26. What is the ratio of the Emissions (1000 metric ton of CO2 equivalent) in 2005 in Croatia to that in Egypt, Arab Rep.?
Your answer should be compact. 0.25. What is the ratio of the Emissions (1000 metric ton of CO2 equivalent) of 2008 in Croatia to that in Egypt, Arab Rep.?
Keep it short and to the point. 0.2. What is the ratio of the Emissions (1000 metric ton of CO2 equivalent) of 1990 in Croatia to that in Finland?
Keep it short and to the point. 0.61. What is the ratio of the Emissions (1000 metric ton of CO2 equivalent) of 2000 in Croatia to that in Finland?
Provide a succinct answer. 0.68. What is the ratio of the Emissions (1000 metric ton of CO2 equivalent) of 2005 in Croatia to that in Finland?
Offer a very short reply. 0.48. What is the ratio of the Emissions (1000 metric ton of CO2 equivalent) in 2008 in Croatia to that in Finland?
Ensure brevity in your answer.  0.59. What is the ratio of the Emissions (1000 metric ton of CO2 equivalent) in 1990 in Croatia to that in France?
Your answer should be very brief. 0.03. What is the ratio of the Emissions (1000 metric ton of CO2 equivalent) in 2000 in Croatia to that in France?
Offer a very short reply. 0.09. What is the ratio of the Emissions (1000 metric ton of CO2 equivalent) of 2005 in Croatia to that in France?
Offer a terse response. 0.11. What is the ratio of the Emissions (1000 metric ton of CO2 equivalent) of 2008 in Croatia to that in France?
Ensure brevity in your answer.  0.17. What is the ratio of the Emissions (1000 metric ton of CO2 equivalent) of 1990 in Cuba to that in Czech Republic?
Give a very brief answer. 0.55. What is the ratio of the Emissions (1000 metric ton of CO2 equivalent) in 2000 in Cuba to that in Czech Republic?
Offer a very short reply. 0.52. What is the ratio of the Emissions (1000 metric ton of CO2 equivalent) in 2005 in Cuba to that in Czech Republic?
Make the answer very short. 0.61. What is the ratio of the Emissions (1000 metric ton of CO2 equivalent) in 2008 in Cuba to that in Czech Republic?
Give a very brief answer. 1.17. What is the ratio of the Emissions (1000 metric ton of CO2 equivalent) of 1990 in Cuba to that in Egypt, Arab Rep.?
Your response must be concise. 0.49. What is the ratio of the Emissions (1000 metric ton of CO2 equivalent) of 2000 in Cuba to that in Egypt, Arab Rep.?
Offer a very short reply. 0.2. What is the ratio of the Emissions (1000 metric ton of CO2 equivalent) in 2005 in Cuba to that in Egypt, Arab Rep.?
Offer a very short reply. 0.21. What is the ratio of the Emissions (1000 metric ton of CO2 equivalent) of 2008 in Cuba to that in Egypt, Arab Rep.?
Give a very brief answer. 0.21. What is the ratio of the Emissions (1000 metric ton of CO2 equivalent) in 1990 in Cuba to that in Finland?
Provide a succinct answer. 0.45. What is the ratio of the Emissions (1000 metric ton of CO2 equivalent) in 2000 in Cuba to that in Finland?
Ensure brevity in your answer.  0.51. What is the ratio of the Emissions (1000 metric ton of CO2 equivalent) in 2005 in Cuba to that in Finland?
Your response must be concise. 0.41. What is the ratio of the Emissions (1000 metric ton of CO2 equivalent) of 2008 in Cuba to that in Finland?
Ensure brevity in your answer.  0.6. What is the ratio of the Emissions (1000 metric ton of CO2 equivalent) in 1990 in Cuba to that in France?
Your response must be concise. 0.03. What is the ratio of the Emissions (1000 metric ton of CO2 equivalent) in 2000 in Cuba to that in France?
Your answer should be compact. 0.06. What is the ratio of the Emissions (1000 metric ton of CO2 equivalent) in 2005 in Cuba to that in France?
Offer a very short reply. 0.1. What is the ratio of the Emissions (1000 metric ton of CO2 equivalent) in 2008 in Cuba to that in France?
Keep it short and to the point. 0.17. What is the ratio of the Emissions (1000 metric ton of CO2 equivalent) of 1990 in Czech Republic to that in Egypt, Arab Rep.?
Provide a short and direct response. 0.9. What is the ratio of the Emissions (1000 metric ton of CO2 equivalent) in 2000 in Czech Republic to that in Egypt, Arab Rep.?
Offer a very short reply. 0.38. What is the ratio of the Emissions (1000 metric ton of CO2 equivalent) of 2005 in Czech Republic to that in Egypt, Arab Rep.?
Keep it short and to the point. 0.34. What is the ratio of the Emissions (1000 metric ton of CO2 equivalent) in 2008 in Czech Republic to that in Egypt, Arab Rep.?
Provide a succinct answer. 0.18. What is the ratio of the Emissions (1000 metric ton of CO2 equivalent) in 1990 in Czech Republic to that in Finland?
Provide a short and direct response. 0.82. What is the ratio of the Emissions (1000 metric ton of CO2 equivalent) of 2000 in Czech Republic to that in Finland?
Ensure brevity in your answer.  0.98. What is the ratio of the Emissions (1000 metric ton of CO2 equivalent) in 2005 in Czech Republic to that in Finland?
Give a very brief answer. 0.68. What is the ratio of the Emissions (1000 metric ton of CO2 equivalent) of 2008 in Czech Republic to that in Finland?
Offer a very short reply. 0.51. What is the ratio of the Emissions (1000 metric ton of CO2 equivalent) of 1990 in Czech Republic to that in France?
Give a very brief answer. 0.05. What is the ratio of the Emissions (1000 metric ton of CO2 equivalent) in 2000 in Czech Republic to that in France?
Provide a short and direct response. 0.12. What is the ratio of the Emissions (1000 metric ton of CO2 equivalent) of 2005 in Czech Republic to that in France?
Give a very brief answer. 0.16. What is the ratio of the Emissions (1000 metric ton of CO2 equivalent) of 2008 in Czech Republic to that in France?
Provide a short and direct response. 0.14. What is the ratio of the Emissions (1000 metric ton of CO2 equivalent) in 1990 in Egypt, Arab Rep. to that in Finland?
Provide a succinct answer. 0.91. What is the ratio of the Emissions (1000 metric ton of CO2 equivalent) of 2000 in Egypt, Arab Rep. to that in Finland?
Keep it short and to the point. 2.6. What is the ratio of the Emissions (1000 metric ton of CO2 equivalent) of 2005 in Egypt, Arab Rep. to that in Finland?
Ensure brevity in your answer.  1.97. What is the ratio of the Emissions (1000 metric ton of CO2 equivalent) of 2008 in Egypt, Arab Rep. to that in Finland?
Offer a very short reply. 2.91. What is the ratio of the Emissions (1000 metric ton of CO2 equivalent) of 1990 in Egypt, Arab Rep. to that in France?
Make the answer very short. 0.05. What is the ratio of the Emissions (1000 metric ton of CO2 equivalent) in 2000 in Egypt, Arab Rep. to that in France?
Provide a succinct answer. 0.33. What is the ratio of the Emissions (1000 metric ton of CO2 equivalent) of 2005 in Egypt, Arab Rep. to that in France?
Keep it short and to the point. 0.46. What is the ratio of the Emissions (1000 metric ton of CO2 equivalent) in 2008 in Egypt, Arab Rep. to that in France?
Your answer should be very brief. 0.82. What is the ratio of the Emissions (1000 metric ton of CO2 equivalent) in 1990 in Finland to that in France?
Your answer should be very brief. 0.06. What is the ratio of the Emissions (1000 metric ton of CO2 equivalent) in 2000 in Finland to that in France?
Provide a short and direct response. 0.13. What is the ratio of the Emissions (1000 metric ton of CO2 equivalent) in 2005 in Finland to that in France?
Ensure brevity in your answer.  0.24. What is the ratio of the Emissions (1000 metric ton of CO2 equivalent) of 2008 in Finland to that in France?
Give a very brief answer. 0.28. What is the difference between the highest and the second highest Emissions (1000 metric ton of CO2 equivalent) of 1990?
Make the answer very short. 2.52e+04. What is the difference between the highest and the second highest Emissions (1000 metric ton of CO2 equivalent) of 2000?
Your answer should be compact. 6681.1. What is the difference between the highest and the second highest Emissions (1000 metric ton of CO2 equivalent) in 2005?
Keep it short and to the point. 3679. What is the difference between the highest and the second highest Emissions (1000 metric ton of CO2 equivalent) in 2008?
Offer a very short reply. 926.3. What is the difference between the highest and the lowest Emissions (1000 metric ton of CO2 equivalent) in 1990?
Your response must be concise. 2.60e+04. What is the difference between the highest and the lowest Emissions (1000 metric ton of CO2 equivalent) in 2000?
Give a very brief answer. 9308.8. What is the difference between the highest and the lowest Emissions (1000 metric ton of CO2 equivalent) in 2005?
Your answer should be compact. 6204.5. What is the difference between the highest and the lowest Emissions (1000 metric ton of CO2 equivalent) of 2008?
Keep it short and to the point. 4485.3. 